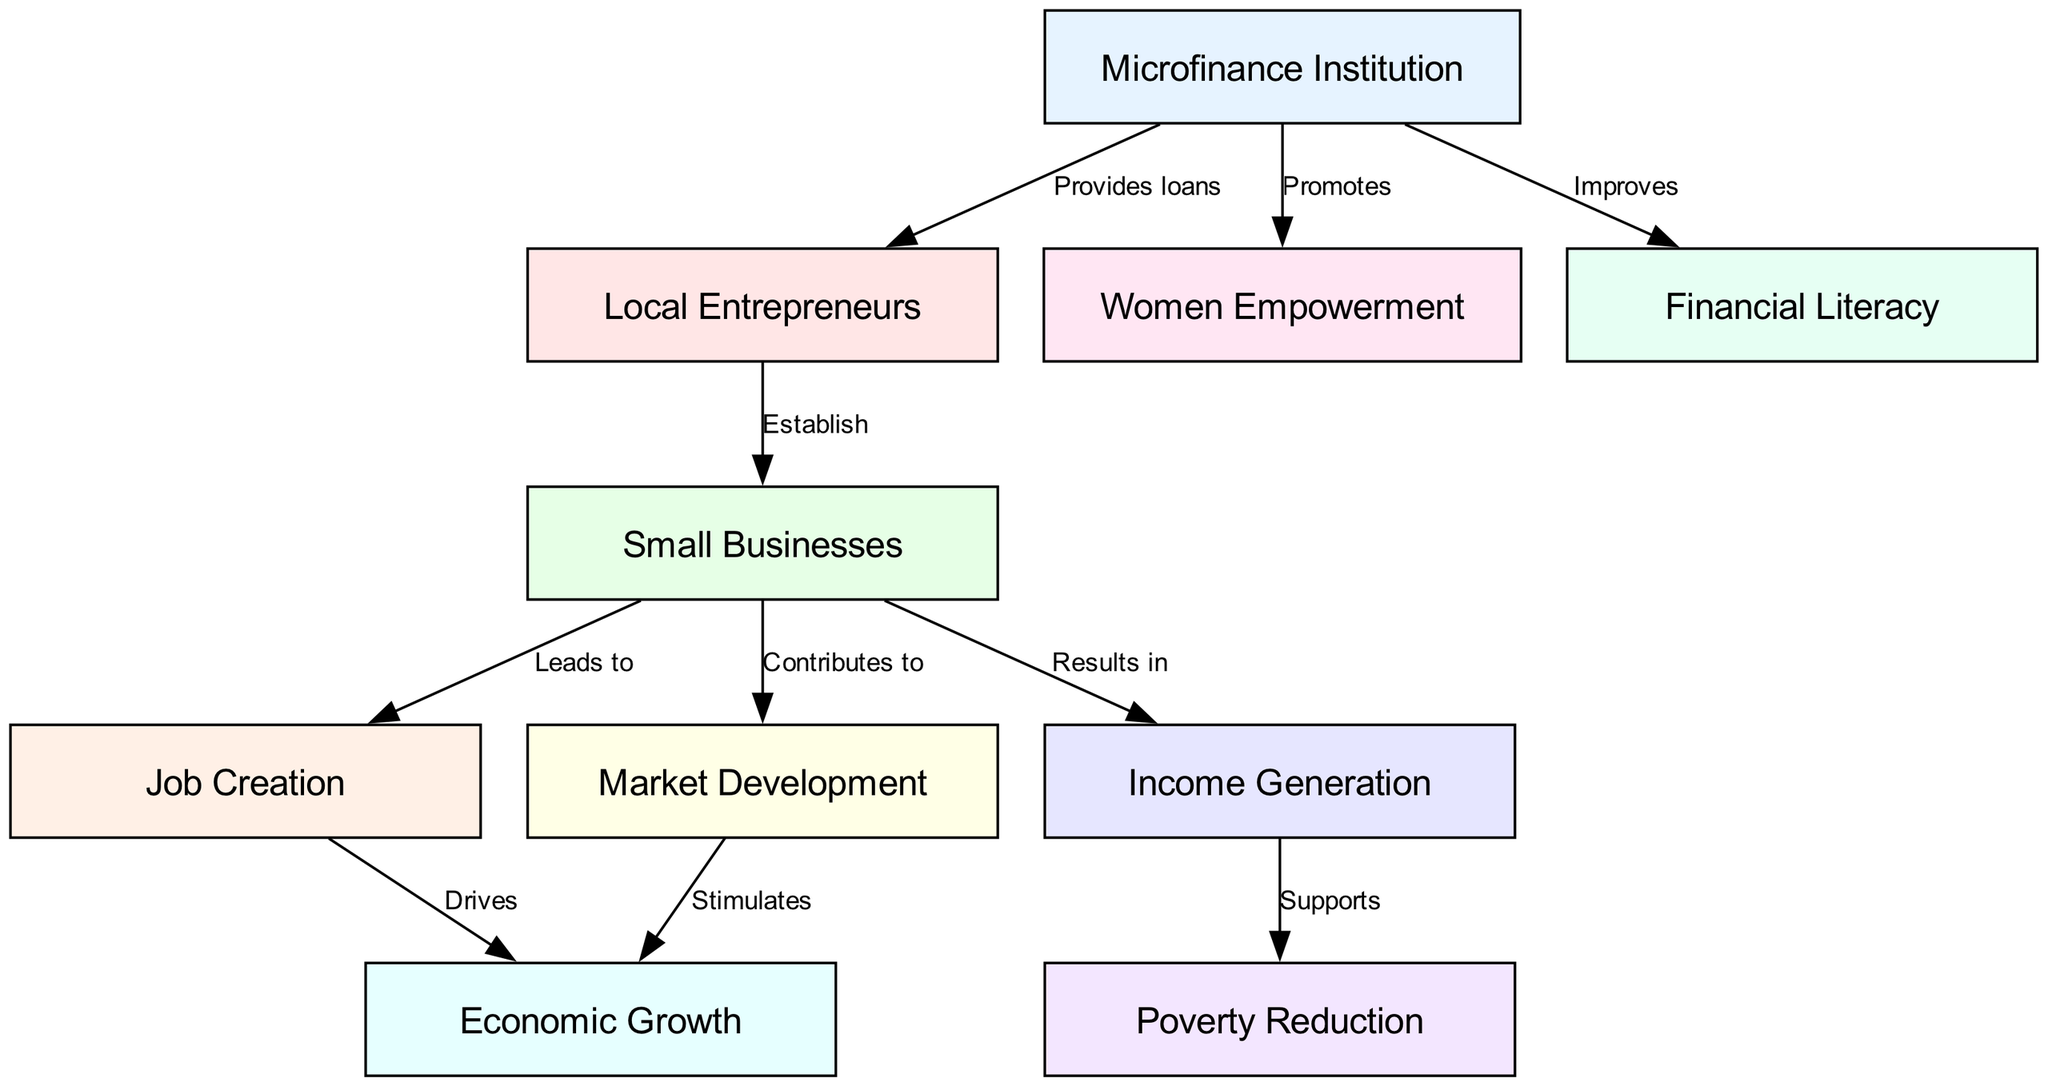What is the starting point in the diagram? The starting point is the "Microfinance Institution," which provides loans to local entrepreneurs, initiating the flow of impact in the diagram.
Answer: Microfinance Institution How many nodes are in the diagram? The total number of nodes is 10, which are all represented in the diagram related to the microfinance program's impact on the local economy.
Answer: 10 What does “Small Businesses” lead to? "Small Businesses" leads to "Job Creation" and "Income Generation," showing the direct results of establishing small enterprises.
Answer: Job Creation, Income Generation What action does the "Microfinance Institution" take towards "Women Empowerment"? The "Microfinance Institution" promotes "Women Empowerment," indicating its role in providing empowerment opportunities through financial support.
Answer: Promotes Which element stimulates "Economic Growth"? "Market Development" and "Job Creation" both stimulate "Economic Growth," indicating key contributors to the broader economic improvement within the community.
Answer: Market Development, Job Creation What supports "Poverty Reduction"? "Income Generation" supports "Poverty Reduction," showing the link between generating income through small businesses and alleviating poverty levels in the community.
Answer: Income Generation Which two nodes are connected by the label "Leads to"? The two nodes connected by the label "Leads to" are "Small Businesses" and "Job Creation," indicating that the establishment of small businesses directly results in job opportunities.
Answer: Small Businesses, Job Creation Why is "Financial Literacy" important in the diagram? "Financial Literacy" is improved by the "Microfinance Institution," signifying its importance in enabling local entrepreneurs to effectively manage their financial resources.
Answer: Improved How does "Market Development" relate to the local economy? "Market Development" stimulates "Economic Growth," illustrating the relationship that developing market opportunities boosts the economy's overall growth.
Answer: Stimulates What is one outcome of "Small Businesses"? "Small Businesses" result in "Income Generation," indicating a direct financial outcome from the successful functioning of small scale enterprises.
Answer: Income Generation 